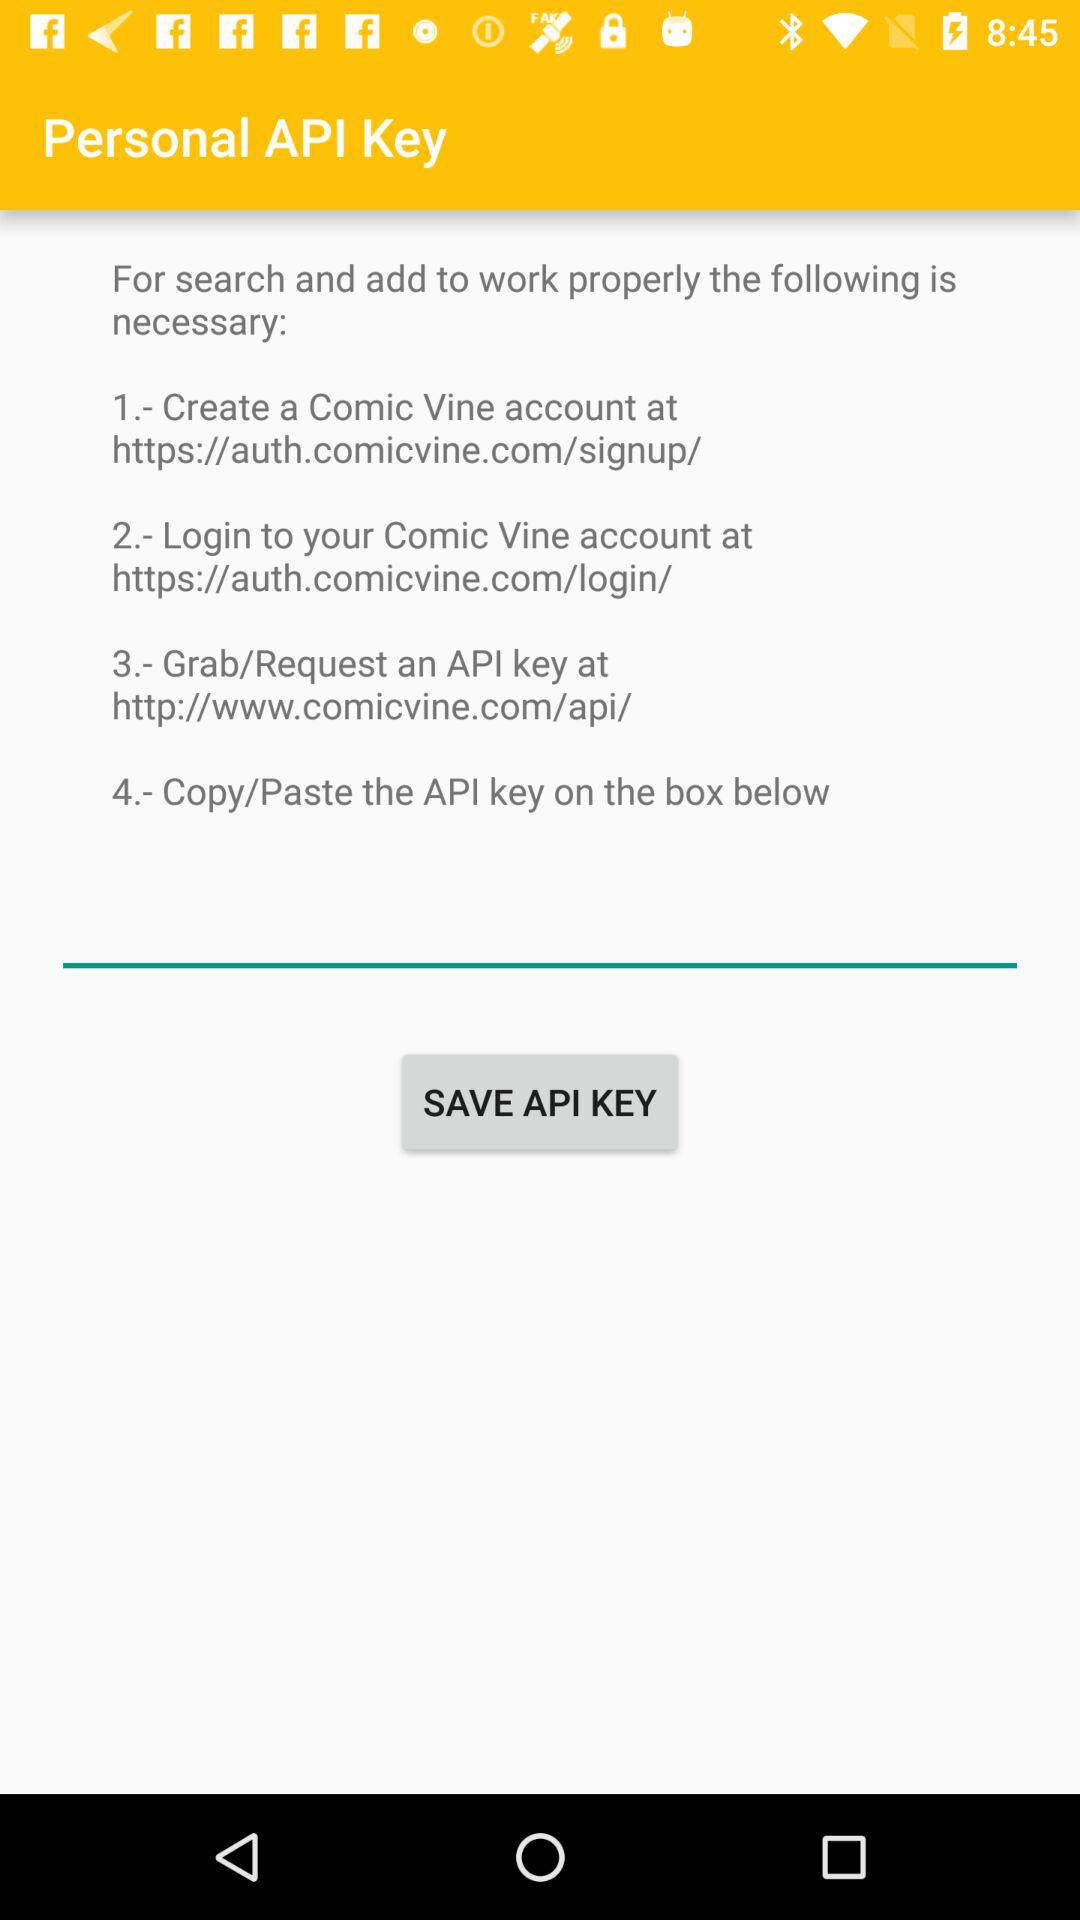How many steps are there to get an API key?
Answer the question using a single word or phrase. 4 